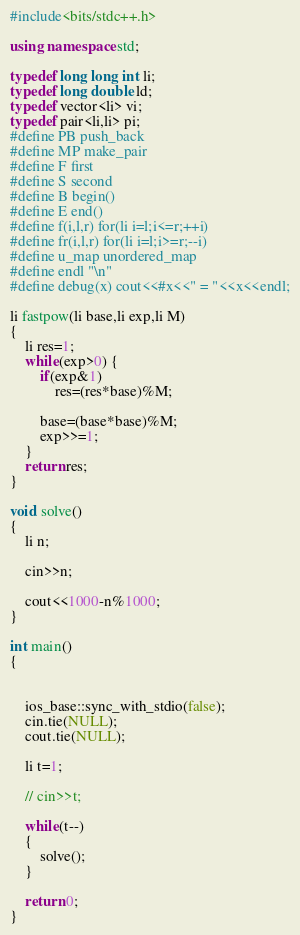Convert code to text. <code><loc_0><loc_0><loc_500><loc_500><_C++_>#include<bits/stdc++.h>

using namespace std;

typedef long long int li;
typedef long double ld;
typedef vector<li> vi;
typedef pair<li,li> pi;
#define PB push_back
#define MP make_pair
#define F first
#define S second
#define B begin()
#define E end()
#define f(i,l,r) for(li i=l;i<=r;++i)
#define fr(i,l,r) for(li i=l;i>=r;--i)
#define u_map unordered_map
#define endl "\n"
#define debug(x) cout<<#x<<" = "<<x<<endl;

li fastpow(li base,li exp,li M) 
{
    li res=1;
    while(exp>0) {
        if(exp&1)
            res=(res*base)%M;

        base=(base*base)%M;
        exp>>=1;
    }
    return res;
}

void solve()
{
    li n;

    cin>>n;

    cout<<1000-n%1000;
}

int main()
{    
    

    ios_base::sync_with_stdio(false);
    cin.tie(NULL);
    cout.tie(NULL);

    li t=1;

    // cin>>t;

    while(t--)
    {
        solve();
    }

    return 0;
}</code> 